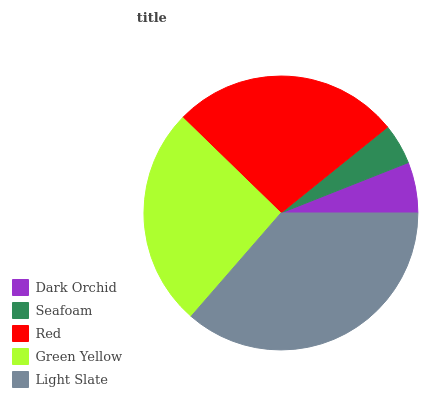Is Seafoam the minimum?
Answer yes or no. Yes. Is Light Slate the maximum?
Answer yes or no. Yes. Is Red the minimum?
Answer yes or no. No. Is Red the maximum?
Answer yes or no. No. Is Red greater than Seafoam?
Answer yes or no. Yes. Is Seafoam less than Red?
Answer yes or no. Yes. Is Seafoam greater than Red?
Answer yes or no. No. Is Red less than Seafoam?
Answer yes or no. No. Is Green Yellow the high median?
Answer yes or no. Yes. Is Green Yellow the low median?
Answer yes or no. Yes. Is Light Slate the high median?
Answer yes or no. No. Is Red the low median?
Answer yes or no. No. 